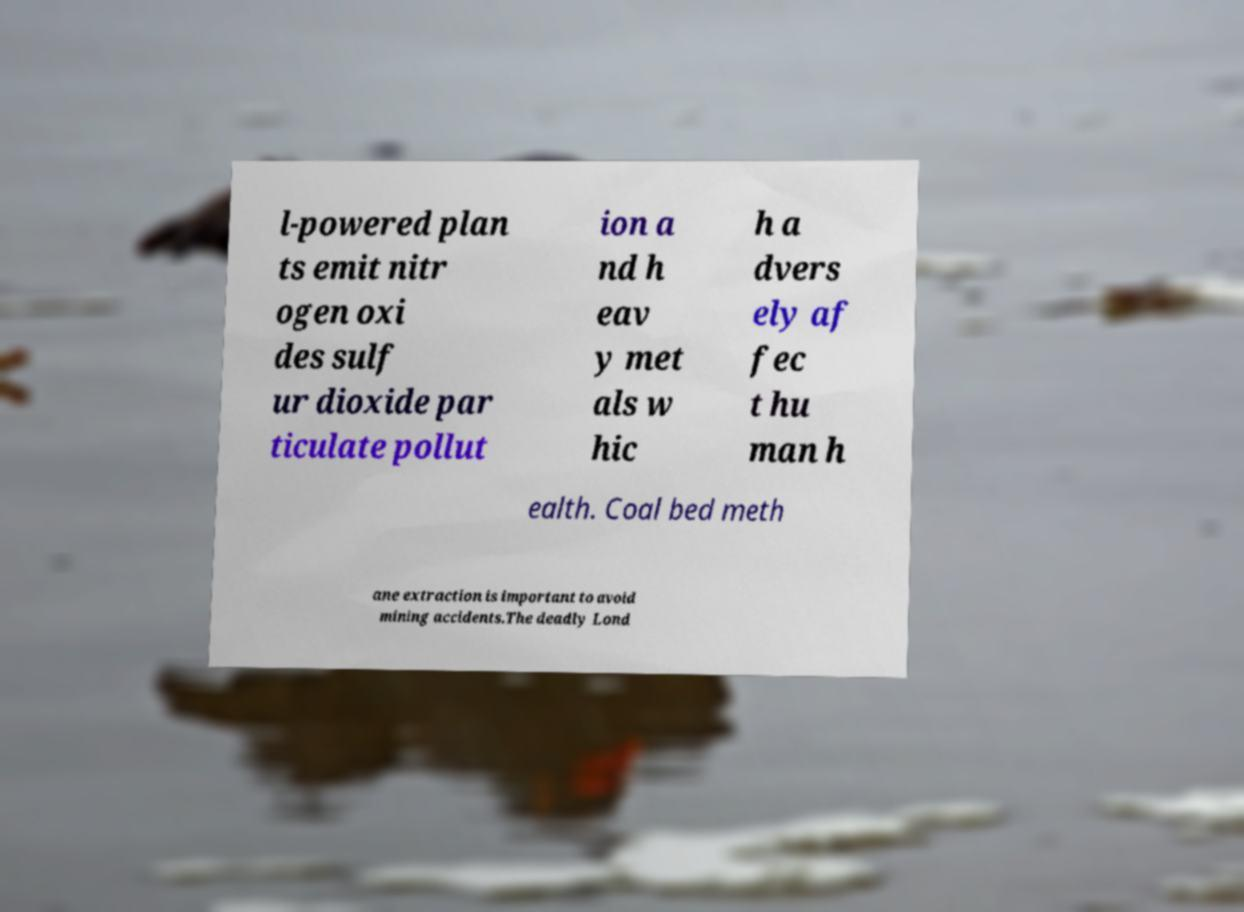What messages or text are displayed in this image? I need them in a readable, typed format. l-powered plan ts emit nitr ogen oxi des sulf ur dioxide par ticulate pollut ion a nd h eav y met als w hic h a dvers ely af fec t hu man h ealth. Coal bed meth ane extraction is important to avoid mining accidents.The deadly Lond 